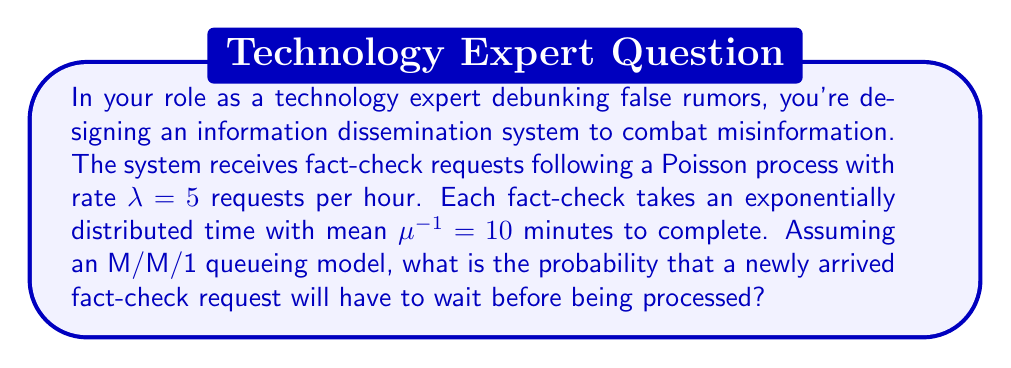Can you answer this question? To solve this problem, we'll use concepts from queueing theory, specifically for an M/M/1 queue. Let's break it down step-by-step:

1) First, we need to calculate the utilization factor $\rho$:
   $\rho = \frac{\lambda}{\mu}$

2) Convert $\lambda$ to the same time unit as $\mu$:
   $\lambda = 5$ requests/hour = $\frac{5}{60} = \frac{1}{12}$ requests/minute

3) Calculate $\mu$:
   $\mu = \frac{1}{10}$ requests/minute

4) Now we can calculate $\rho$:
   $\rho = \frac{\lambda}{\mu} = \frac{1/12}{1/10} = \frac{10}{12} = \frac{5}{6} \approx 0.833$

5) In an M/M/1 queue, the probability that an arriving customer has to wait (i.e., the system is busy) is equal to the utilization factor $\rho$.

Therefore, the probability that a newly arrived fact-check request will have to wait is $\frac{5}{6}$ or approximately 0.833.
Answer: $\frac{5}{6}$ 